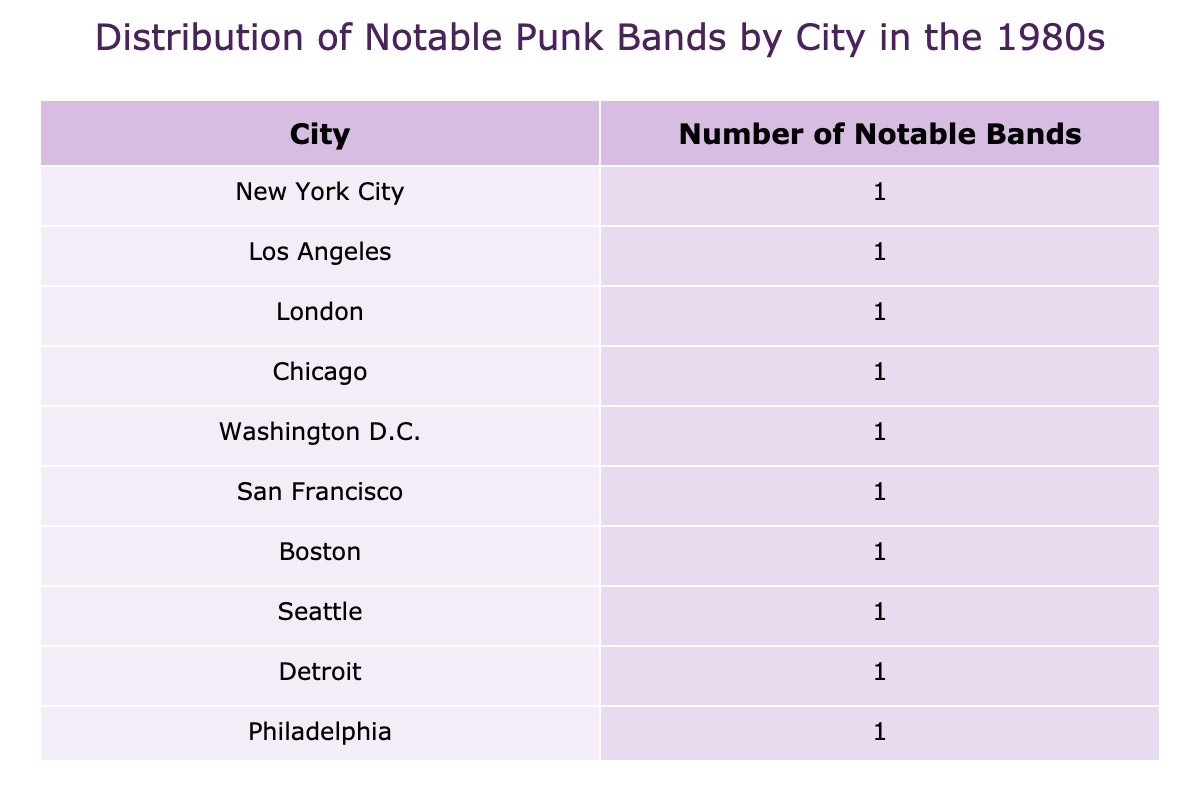What city has the highest number of notable punk bands? By reviewing the table, I see Los Angeles has 1 notable band, New York City has 1, London has 1, and so on. However, Chicago, with 1 band, and other cities each also have 1 band. Since no city has multiple bands, the maximum count for all listed cities is 1.
Answer: 1 Which city has the smallest number of notable punk bands? Each city has at least 1 band according to the table data. Since the minimum value across all cities is consistent, the answer is that they all have the same quantity.
Answer: 1 Is there a city with more than one notable punk band? Upon examining the table, I notice that no city appears more than once, indicating each listed city represents a distinct punk band without duplication.
Answer: No Which cities have notable punk bands released in the early '80s? Filtering the table for notable release years, I find bands listed with notable releases in 1980-1983 include Black Flag in Los Angeles (1981), The Effigies in Chicago (1982), Minor Threat in Washington D.C. (1983), and others. Summarizing those cities gives me the answer.
Answer: Los Angeles, Chicago, Washington D.C., San Francisco, Orange County, Seattle, Detroit, Portland What percentage of the listed bands were from California? From the table, I count bands from California: Black Flag and Social Distortion from Los Angeles and Orange County, respectively, giving me a count of 2 bands out of a total of 12. (2/12) * 100 = 16.67%.
Answer: 16.67% 